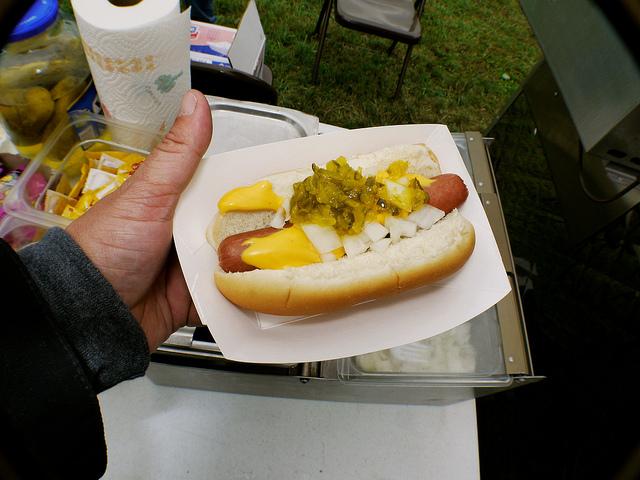Is this picture taken in a restaurant?
Short answer required. No. Is this a whole hot dog?
Answer briefly. Yes. Is there cheese on the hot dog?
Keep it brief. Yes. Is this European bread?
Concise answer only. No. Do these hot dog look like they were grilled?
Answer briefly. No. How many hot dogs are on the plate?
Give a very brief answer. 1. 